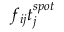<formula> <loc_0><loc_0><loc_500><loc_500>f _ { i j } t _ { j } ^ { s p o t }</formula> 